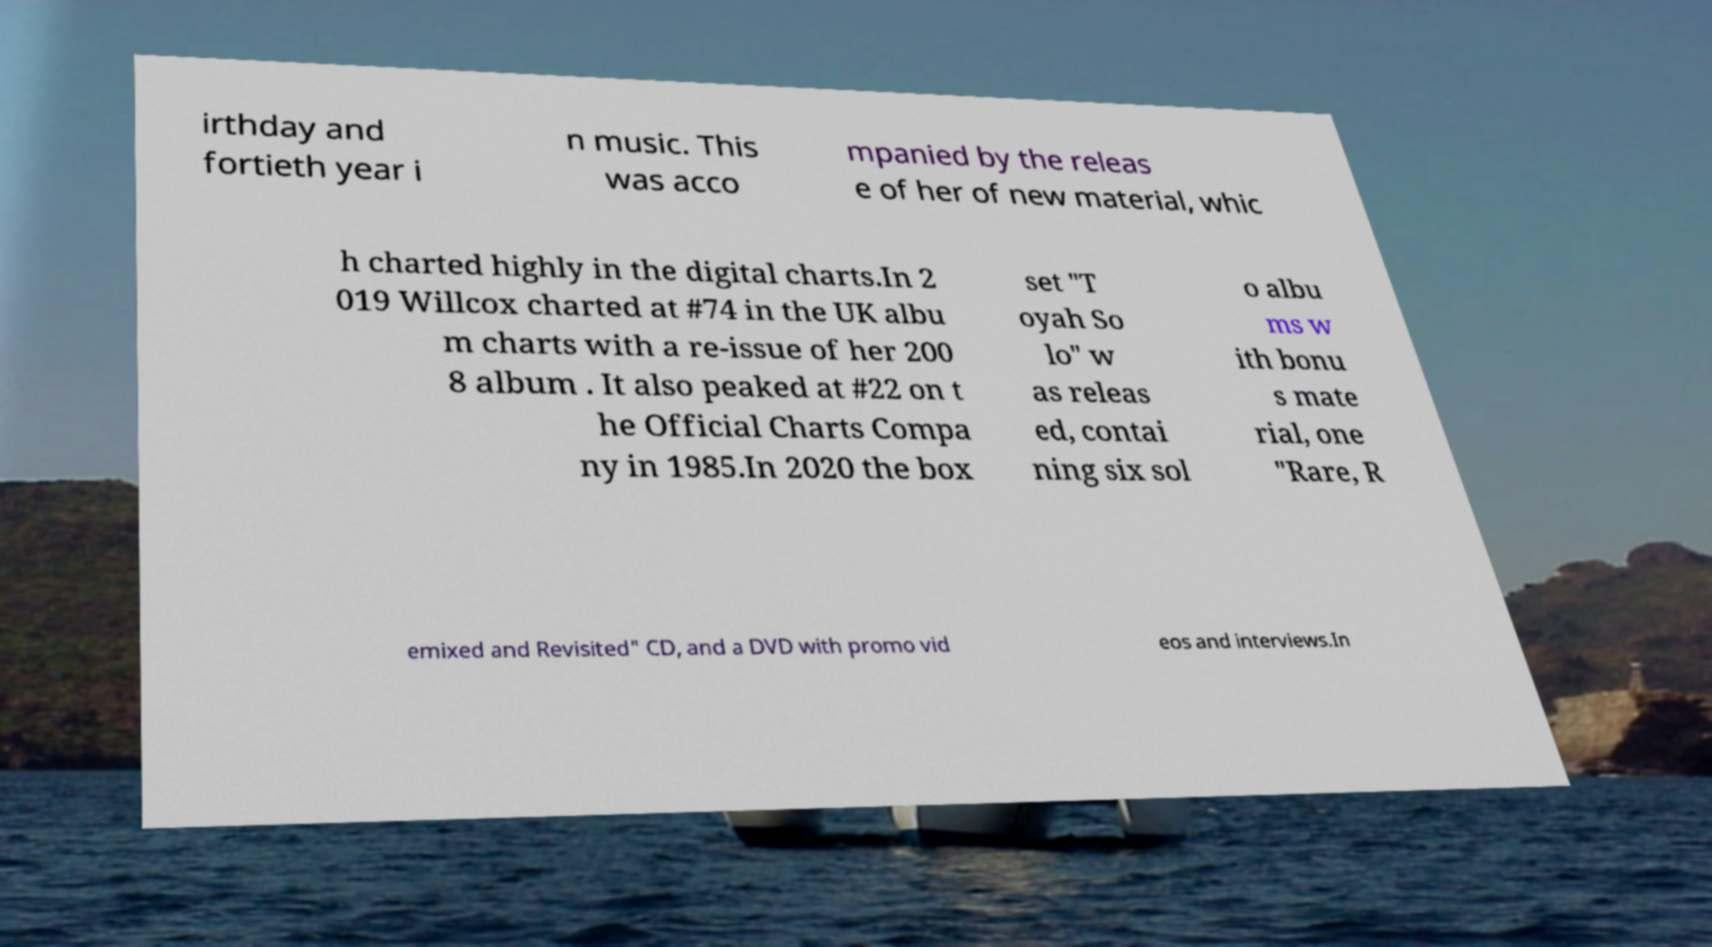Can you accurately transcribe the text from the provided image for me? irthday and fortieth year i n music. This was acco mpanied by the releas e of her of new material, whic h charted highly in the digital charts.In 2 019 Willcox charted at #74 in the UK albu m charts with a re-issue of her 200 8 album . It also peaked at #22 on t he Official Charts Compa ny in 1985.In 2020 the box set "T oyah So lo" w as releas ed, contai ning six sol o albu ms w ith bonu s mate rial, one "Rare, R emixed and Revisited" CD, and a DVD with promo vid eos and interviews.In 